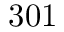Convert formula to latex. <formula><loc_0><loc_0><loc_500><loc_500>3 0 1</formula> 